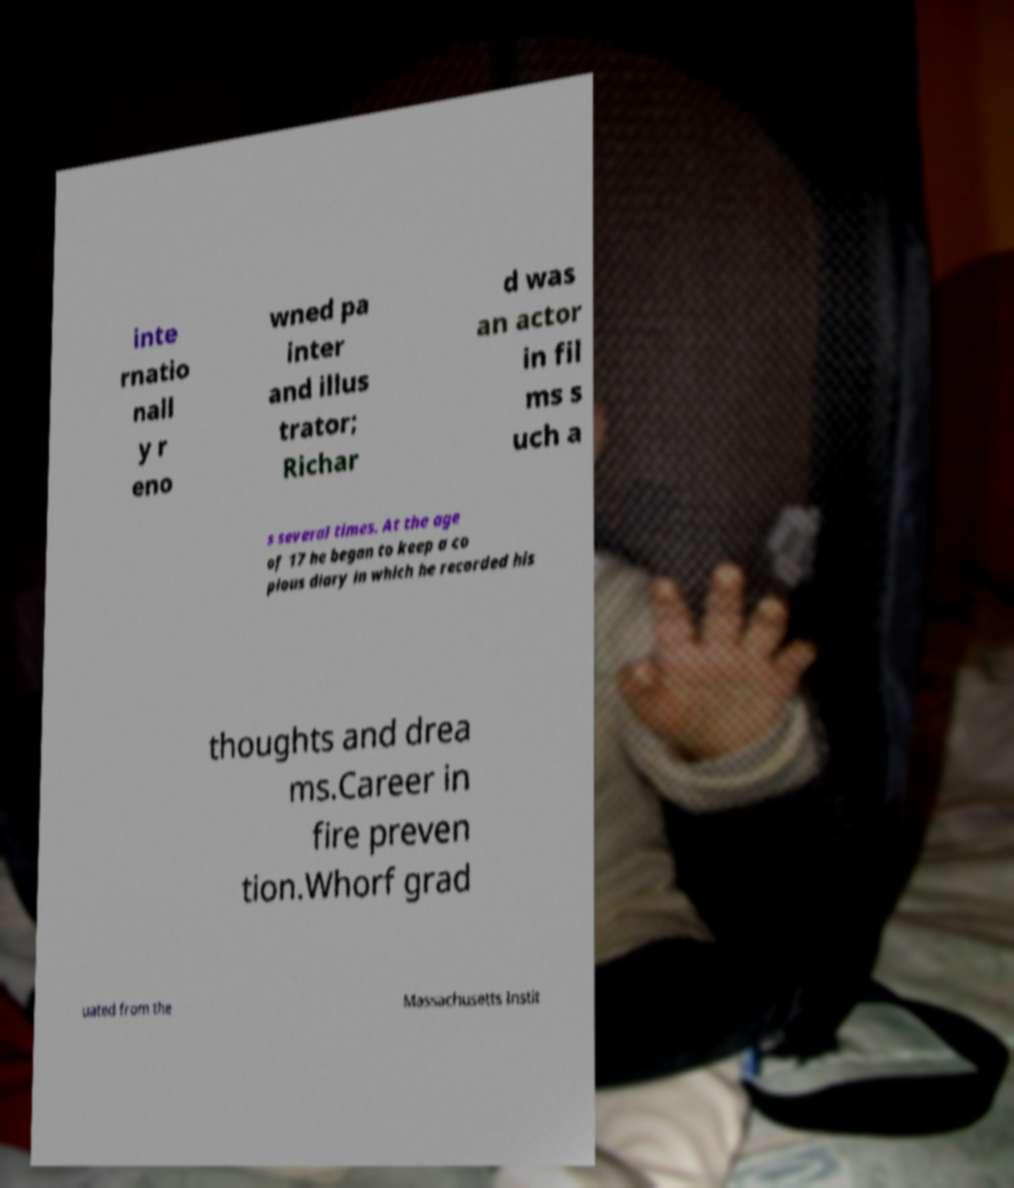There's text embedded in this image that I need extracted. Can you transcribe it verbatim? inte rnatio nall y r eno wned pa inter and illus trator; Richar d was an actor in fil ms s uch a s several times. At the age of 17 he began to keep a co pious diary in which he recorded his thoughts and drea ms.Career in fire preven tion.Whorf grad uated from the Massachusetts Instit 